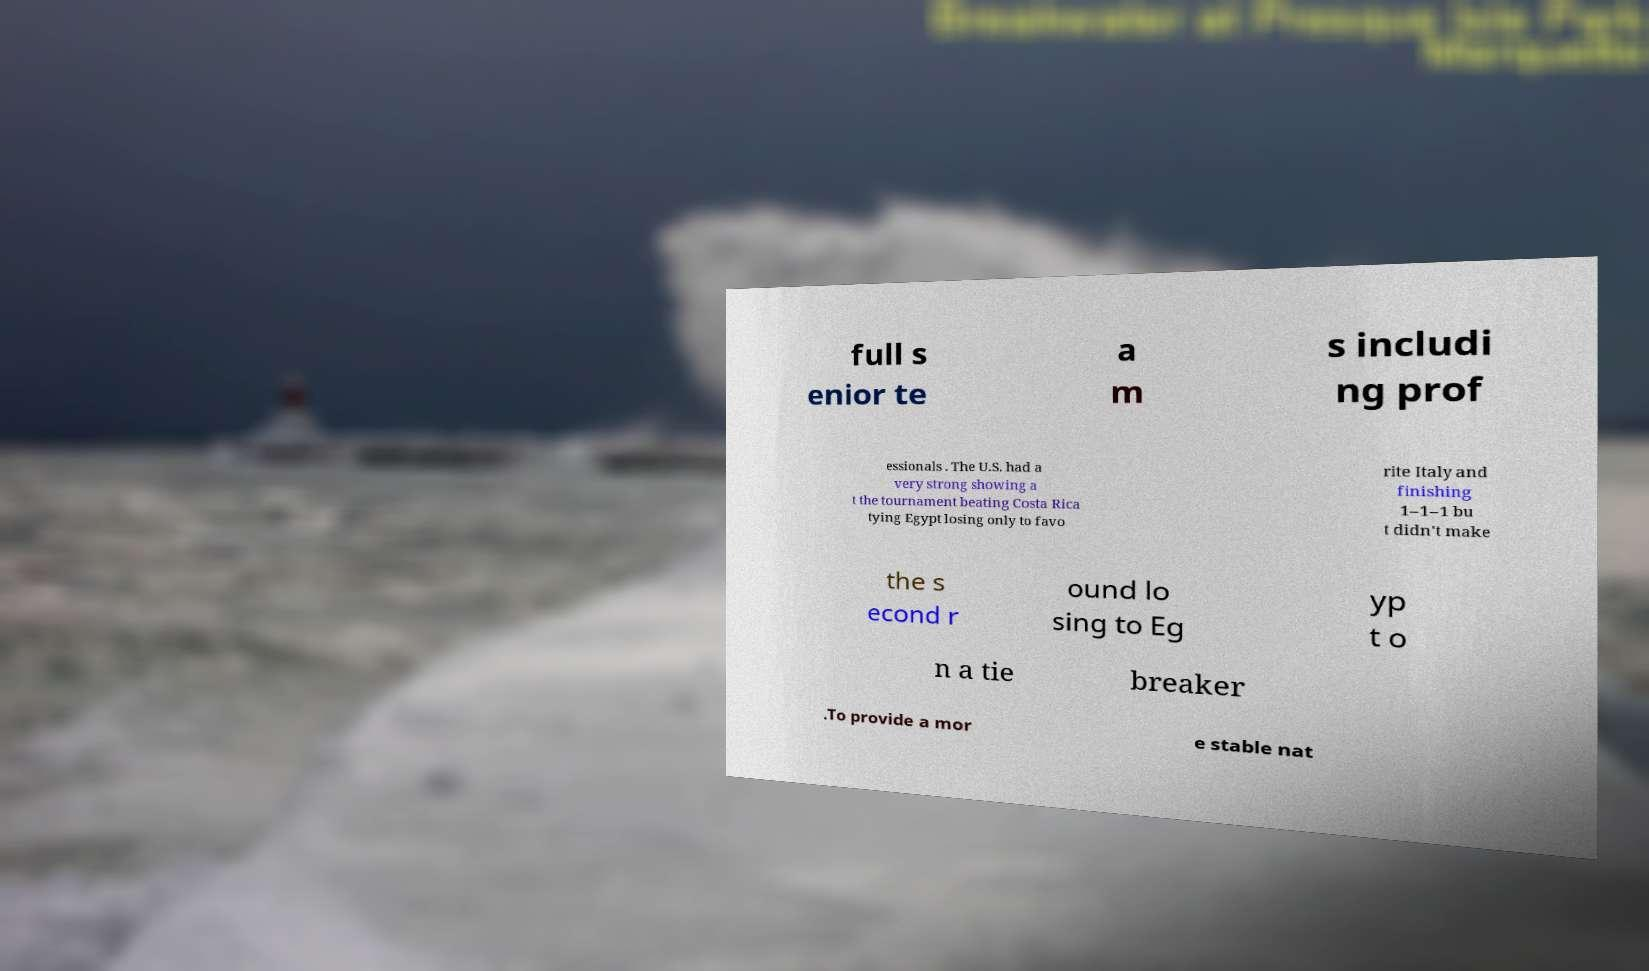What messages or text are displayed in this image? I need them in a readable, typed format. full s enior te a m s includi ng prof essionals . The U.S. had a very strong showing a t the tournament beating Costa Rica tying Egypt losing only to favo rite Italy and finishing 1–1–1 bu t didn't make the s econd r ound lo sing to Eg yp t o n a tie breaker .To provide a mor e stable nat 